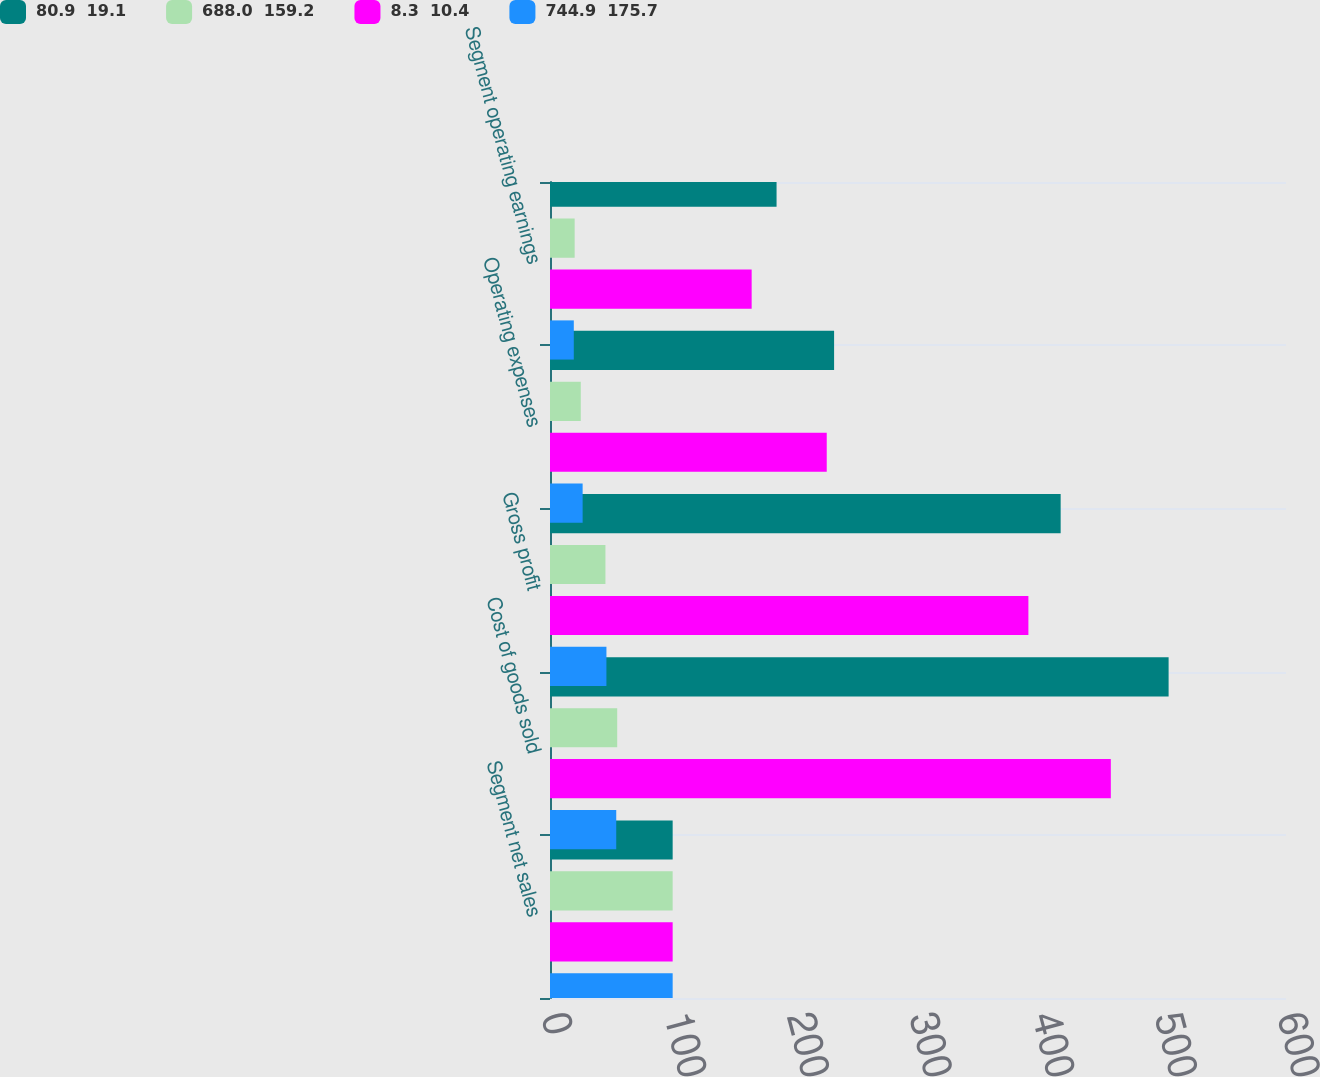Convert chart to OTSL. <chart><loc_0><loc_0><loc_500><loc_500><stacked_bar_chart><ecel><fcel>Segment net sales<fcel>Cost of goods sold<fcel>Gross profit<fcel>Operating expenses<fcel>Segment operating earnings<nl><fcel>80.9  19.1<fcel>100<fcel>504.3<fcel>416.3<fcel>231.6<fcel>184.7<nl><fcel>688.0  159.2<fcel>100<fcel>54.8<fcel>45.2<fcel>25.1<fcel>20.1<nl><fcel>8.3  10.4<fcel>100<fcel>457.2<fcel>390<fcel>225.6<fcel>164.4<nl><fcel>744.9  175.7<fcel>100<fcel>54<fcel>46<fcel>26.6<fcel>19.4<nl></chart> 